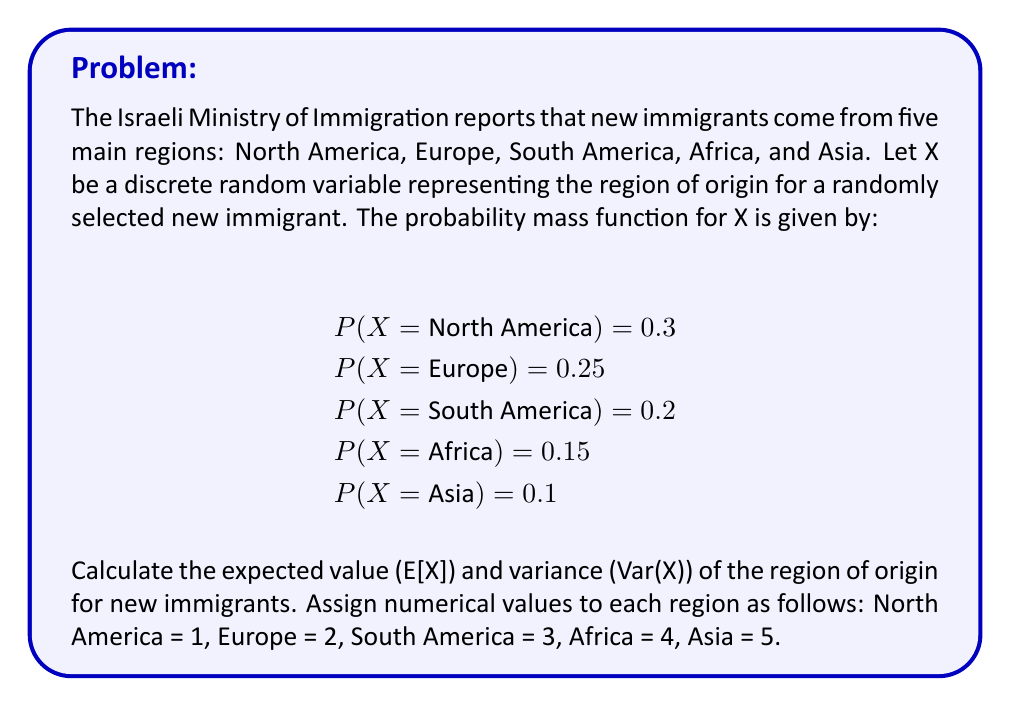Can you solve this math problem? To solve this problem, we'll follow these steps:

1. Calculate the expected value E[X]
2. Calculate E[X^2]
3. Use E[X] and E[X^2] to find the variance Var(X)

Step 1: Calculate E[X]

The expected value is given by the formula:

$$E[X] = \sum_{i=1}^{n} x_i \cdot P(X = x_i)$$

Where $x_i$ are the possible values of X and P(X = x_i) are their respective probabilities.

E[X] = 1 * 0.3 + 2 * 0.25 + 3 * 0.2 + 4 * 0.15 + 5 * 0.1
     = 0.3 + 0.5 + 0.6 + 0.6 + 0.5
     = 2.5

Step 2: Calculate E[X^2]

We need E[X^2] to calculate the variance. Using the same formula:

E[X^2] = 1^2 * 0.3 + 2^2 * 0.25 + 3^2 * 0.2 + 4^2 * 0.15 + 5^2 * 0.1
       = 1 * 0.3 + 4 * 0.25 + 9 * 0.2 + 16 * 0.15 + 25 * 0.1
       = 0.3 + 1 + 1.8 + 2.4 + 2.5
       = 8

Step 3: Calculate Var(X)

The variance is given by the formula:

$$Var(X) = E[X^2] - (E[X])^2$$

Var(X) = 8 - (2.5)^2
       = 8 - 6.25
       = 1.75
Answer: E[X] = 2.5, Var(X) = 1.75 